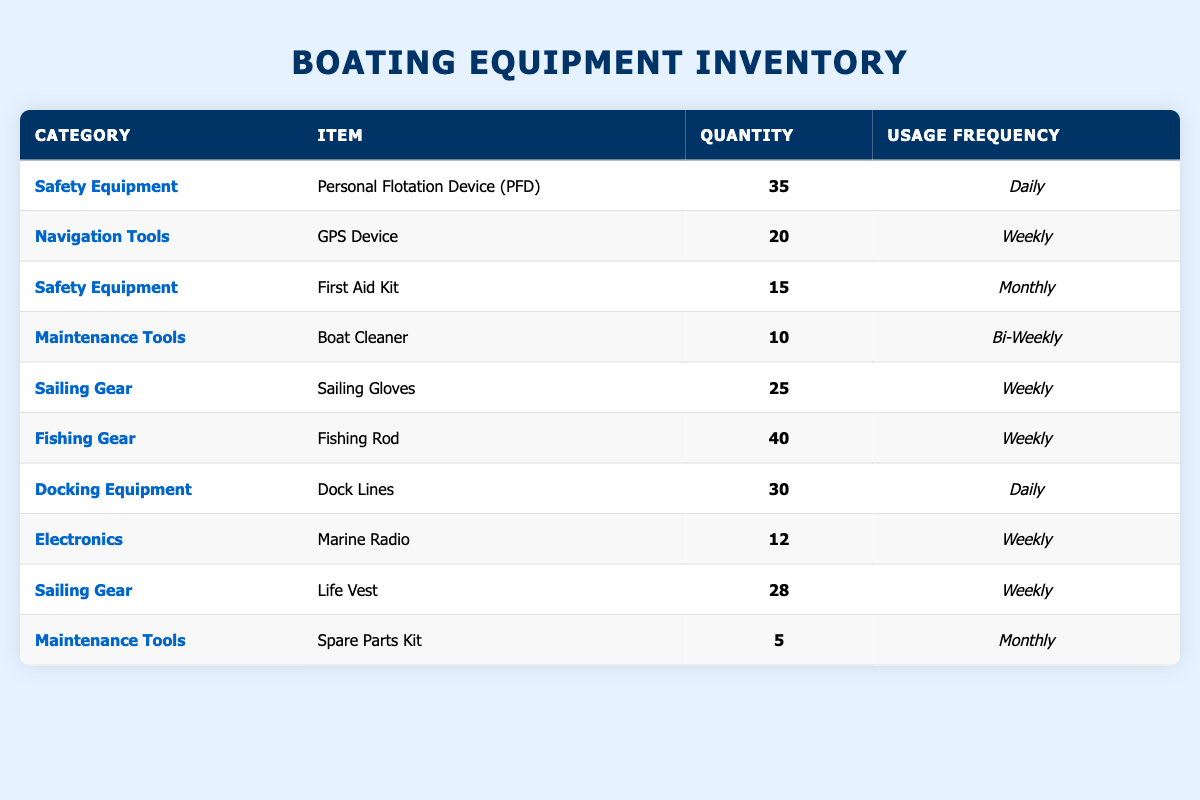What is the total quantity of Personal Flotation Devices available? The table shows that there are 35 Personal Flotation Devices listed under the Safety Equipment category. Therefore, the total quantity is simply that number.
Answer: 35 How many items are categorized under Maintenance Tools? There are two items listed under Maintenance Tools: Boat Cleaner and Spare Parts Kit. Therefore, the number of items in this category is 2.
Answer: 2 What is the usage frequency of the Fishing Rod? According to the table, the Fishing Rod is listed under the Fishing Gear category and has a usage frequency of Weekly. This is directly stated in the table.
Answer: Weekly Which category has the highest quantity of items? The Fishing Gear category has the highest quantity with 40 Fishing Rods. Looking across all categories, no other item exceeds this quantity.
Answer: Fishing Gear Are there any items that are used daily? Yes, there are two items listed with a daily usage frequency: Personal Flotation Device (PFD) and Dock Lines. This can be confirmed by examining the usage frequency column.
Answer: Yes What is the average quantity of items across all categories? To find the average, first sum all the quantities: 35 + 20 + 15 + 10 + 25 + 40 + 30 + 12 + 28 + 5 =  320. Then divide this total by the number of items, which is 10. So, 320 divided by 10 equals 32.
Answer: 32 What percentage of the total inventory is categorized as Safety Equipment? There are two items in the Safety Equipment category (Personal Flotation Device and First Aid Kit), totaling 50 in quantity (35 + 15). The grand total of all items is 320. The percentage is calculated as (50/320) * 100, which approximately equals 15.625%.
Answer: 15.625% Is there a specific item in the Electronics category that is used weekly? Yes, the Marine Radio is listed under Electronics and is noted to be used weekly. This is clearly stated in the usage frequency column.
Answer: Yes How many more Dock Lines than First Aid Kits are there? The table states there are 30 Dock Lines and 15 First Aid Kits. To find the difference, subtract the quantity of First Aid Kits from Dock Lines, which is 30 - 15 = 15.
Answer: 15 